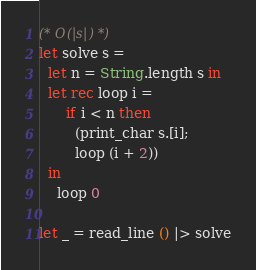<code> <loc_0><loc_0><loc_500><loc_500><_OCaml_>(* O(|s|) *)
let solve s =
  let n = String.length s in
  let rec loop i =
      if i < n then
        (print_char s.[i];
        loop (i + 2))
  in
    loop 0

let _ = read_line () |> solve</code> 